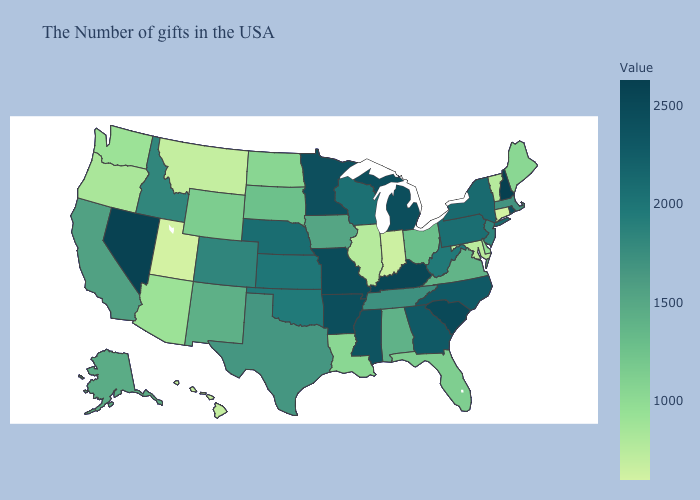Among the states that border Wyoming , which have the highest value?
Be succinct. Nebraska. Does North Carolina have the highest value in the South?
Concise answer only. No. Does Idaho have the lowest value in the USA?
Give a very brief answer. No. Among the states that border Kentucky , which have the lowest value?
Concise answer only. Indiana. 